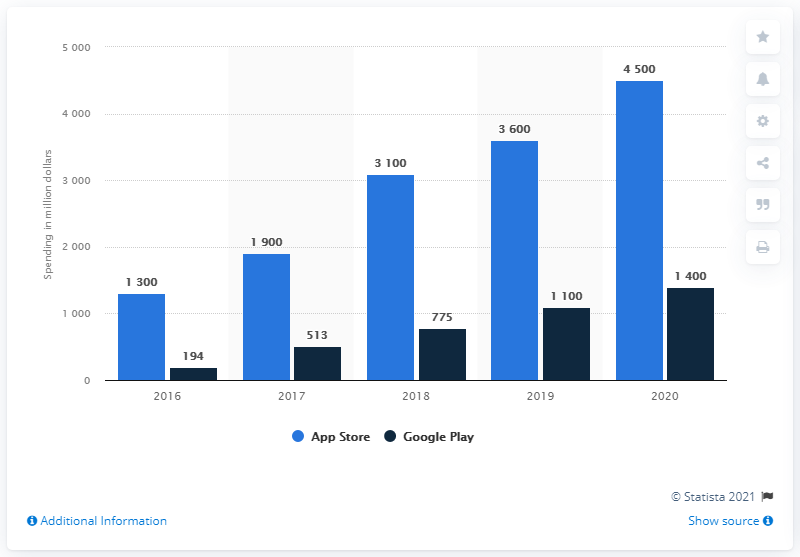Point out several critical features in this image. In 2020, the amount of user spending on the Google Play Store was approximately 1,400. In 2020, the leading subscription apps via the App Store had an average user spend of approximately 4,500 US dollars. In 2020, the user spending on the leading subscription apps via the App Store reached 4.5 billion U.S. dollars. 